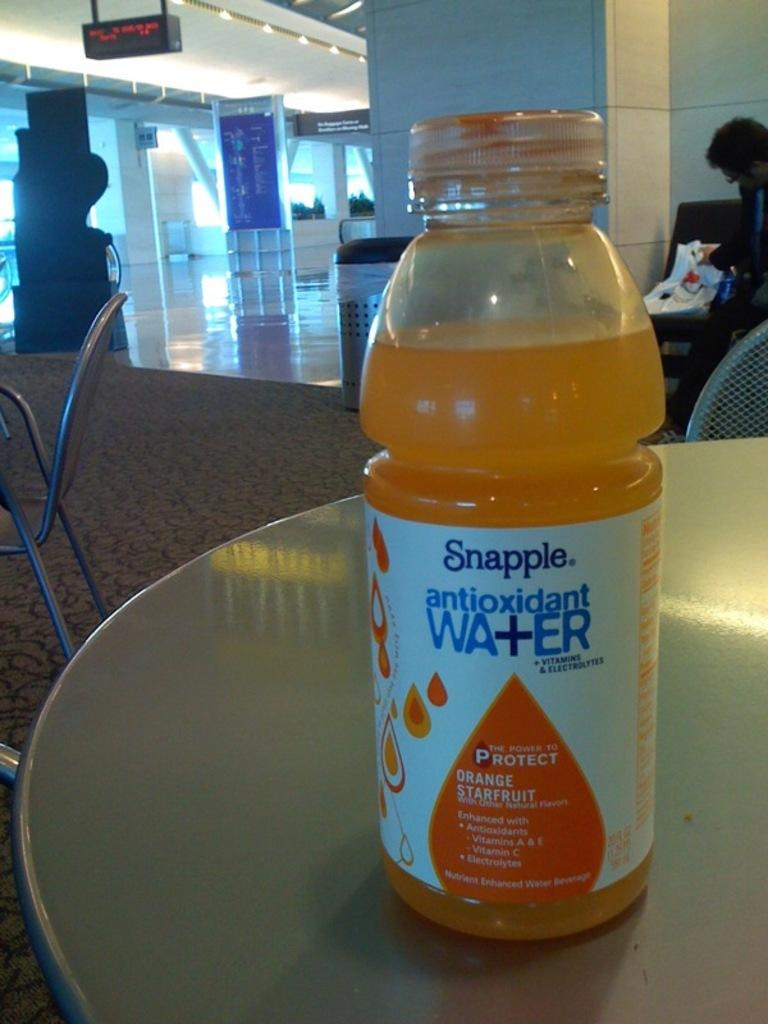What object is placed on the table in the image? There is a bottle on the table. What type of furniture is present in the image? There is a chair in the image. What can be seen in the background of the image? There is a wall and a board in the background. Can you describe the person in the background? There is a person in the background, but the facts do not provide any information about their role or actions. How many clocks are visible on the wall in the image? There are no clocks visible on the wall in the image. What type of writer is present in the image? There is no writer present in the image. 